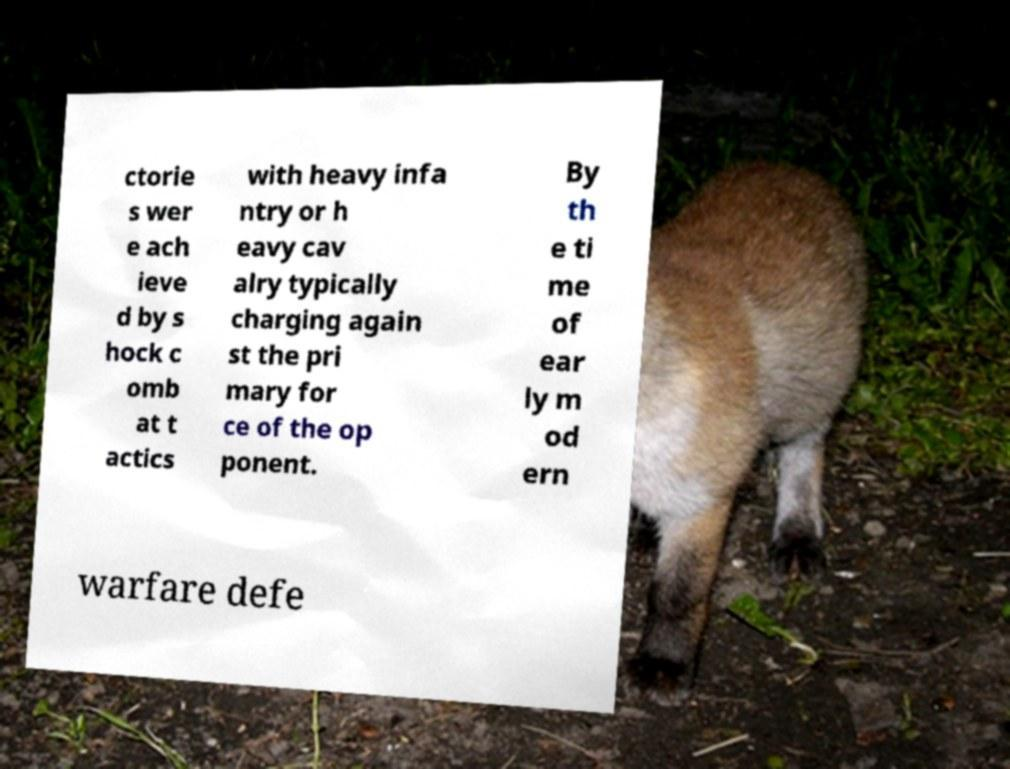There's text embedded in this image that I need extracted. Can you transcribe it verbatim? ctorie s wer e ach ieve d by s hock c omb at t actics with heavy infa ntry or h eavy cav alry typically charging again st the pri mary for ce of the op ponent. By th e ti me of ear ly m od ern warfare defe 